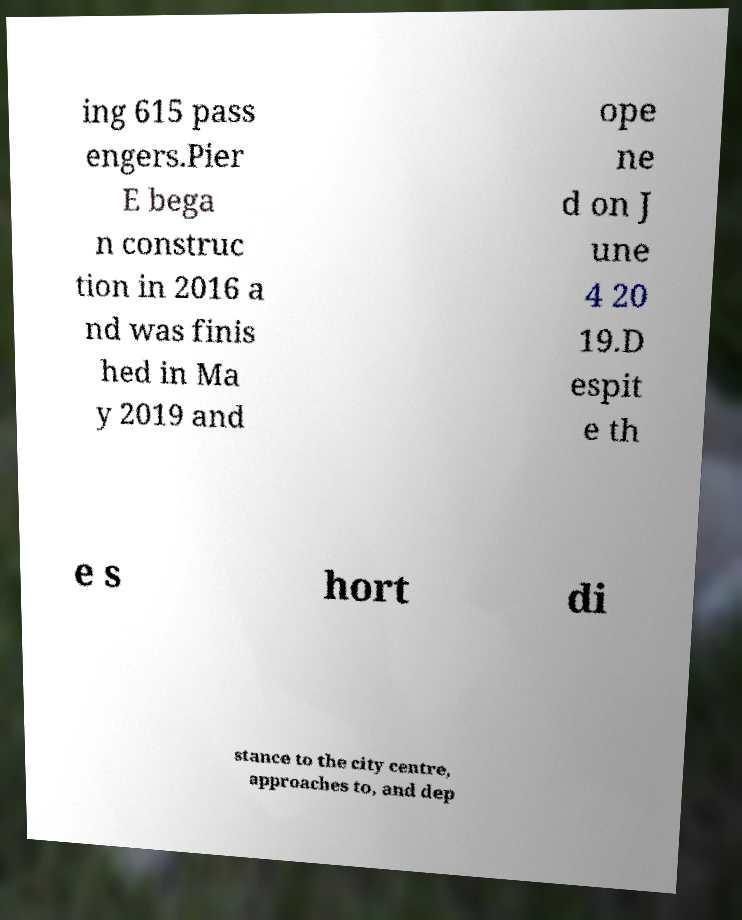For documentation purposes, I need the text within this image transcribed. Could you provide that? ing 615 pass engers.Pier E bega n construc tion in 2016 a nd was finis hed in Ma y 2019 and ope ne d on J une 4 20 19.D espit e th e s hort di stance to the city centre, approaches to, and dep 